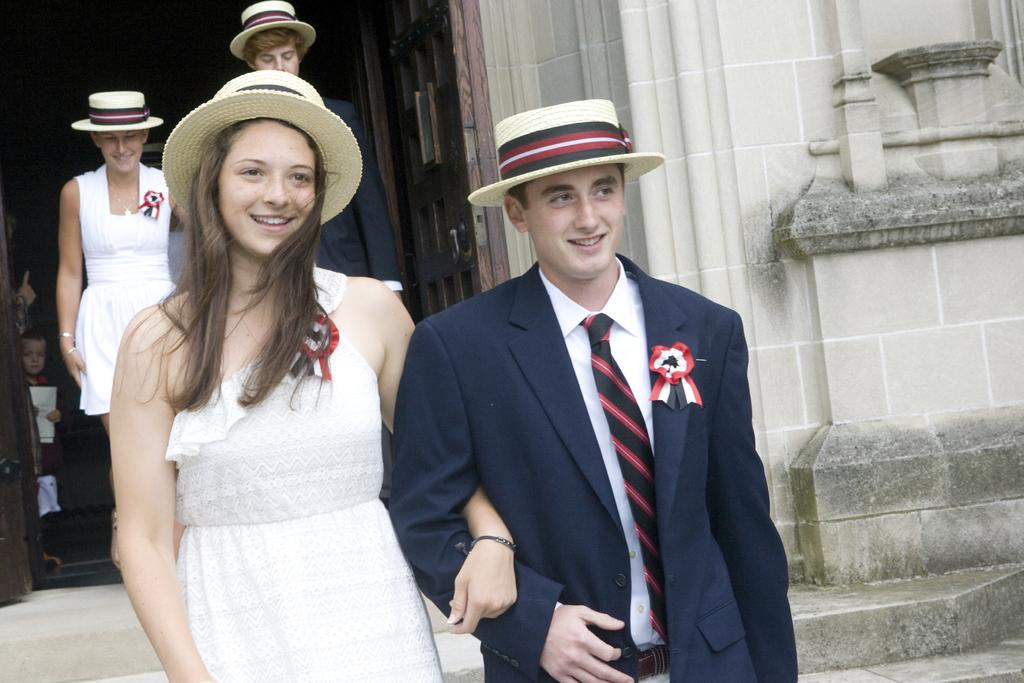How many couples are present in the image? There are two couples in the image. What are the couples doing in the image? The couples are walking. What are the individuals in the couples wearing on their heads? The individuals in the couples are wearing hats. What can be seen in the background of the image? There is a wall visible in the image. What type of knee support is visible on the individuals in the image? There is no knee support visible on the individuals in the image. How does the fireman extinguish the fire in the image? There is no fireman or fire present in the image. 